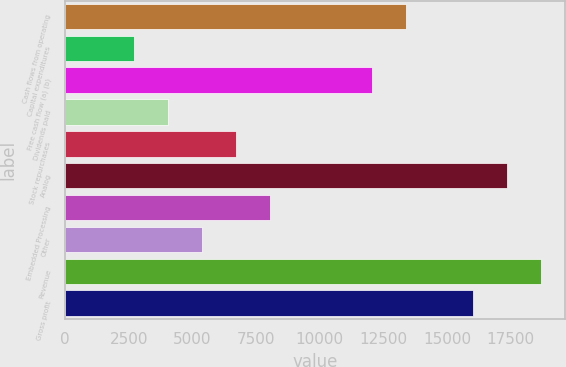<chart> <loc_0><loc_0><loc_500><loc_500><bar_chart><fcel>Cash flows from operating<fcel>Capital expenditures<fcel>Free cash flow (a) (b)<fcel>Dividends paid<fcel>Stock repurchases<fcel>Analog<fcel>Embedded Processing<fcel>Other<fcel>Revenue<fcel>Gross profit<nl><fcel>13370<fcel>2686<fcel>12034.5<fcel>4021.5<fcel>6692.5<fcel>17376.5<fcel>8028<fcel>5357<fcel>18712<fcel>16041<nl></chart> 